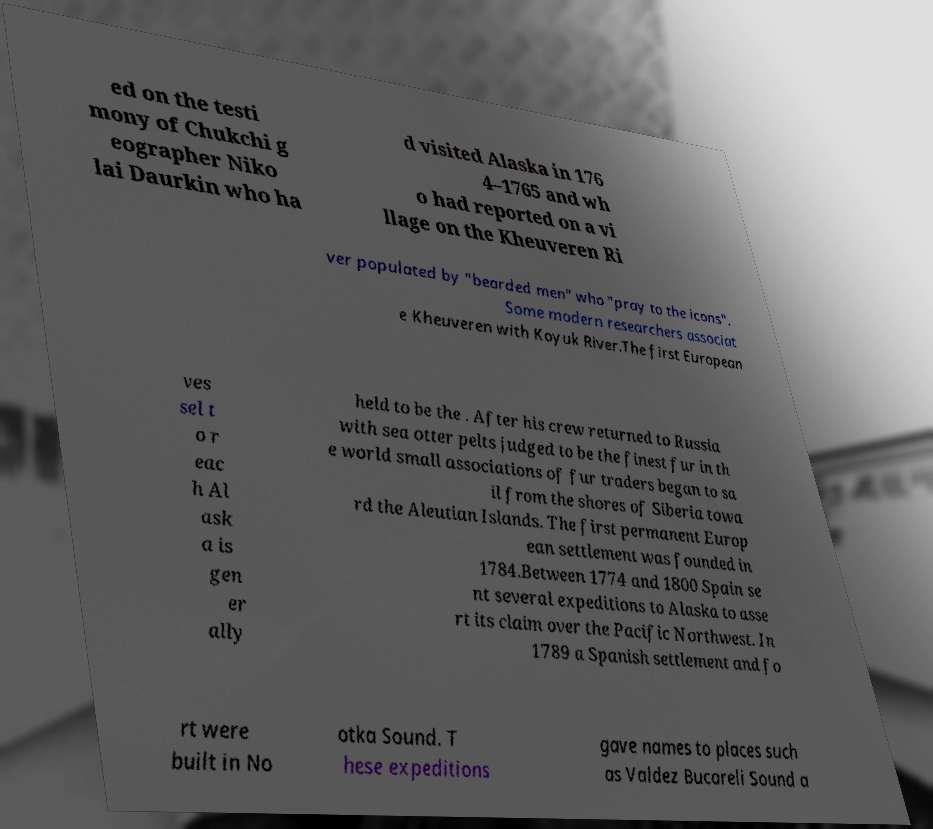I need the written content from this picture converted into text. Can you do that? ed on the testi mony of Chukchi g eographer Niko lai Daurkin who ha d visited Alaska in 176 4–1765 and wh o had reported on a vi llage on the Kheuveren Ri ver populated by "bearded men" who "pray to the icons". Some modern researchers associat e Kheuveren with Koyuk River.The first European ves sel t o r eac h Al ask a is gen er ally held to be the . After his crew returned to Russia with sea otter pelts judged to be the finest fur in th e world small associations of fur traders began to sa il from the shores of Siberia towa rd the Aleutian Islands. The first permanent Europ ean settlement was founded in 1784.Between 1774 and 1800 Spain se nt several expeditions to Alaska to asse rt its claim over the Pacific Northwest. In 1789 a Spanish settlement and fo rt were built in No otka Sound. T hese expeditions gave names to places such as Valdez Bucareli Sound a 